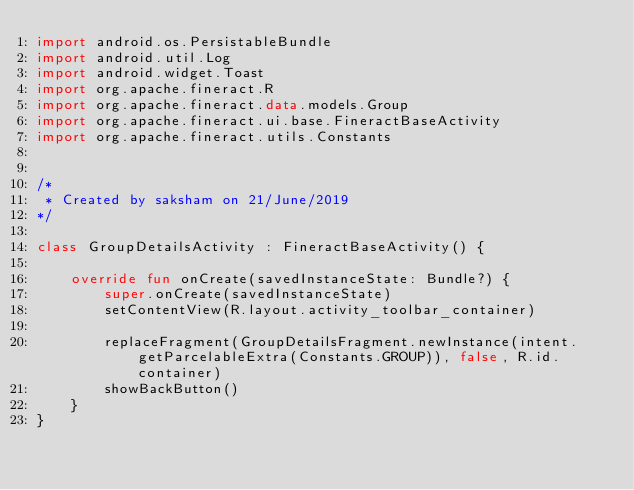<code> <loc_0><loc_0><loc_500><loc_500><_Kotlin_>import android.os.PersistableBundle
import android.util.Log
import android.widget.Toast
import org.apache.fineract.R
import org.apache.fineract.data.models.Group
import org.apache.fineract.ui.base.FineractBaseActivity
import org.apache.fineract.utils.Constants


/*
 * Created by saksham on 21/June/2019
*/

class GroupDetailsActivity : FineractBaseActivity() {

    override fun onCreate(savedInstanceState: Bundle?) {
        super.onCreate(savedInstanceState)
        setContentView(R.layout.activity_toolbar_container)

        replaceFragment(GroupDetailsFragment.newInstance(intent.getParcelableExtra(Constants.GROUP)), false, R.id.container)
        showBackButton()
    }
}</code> 